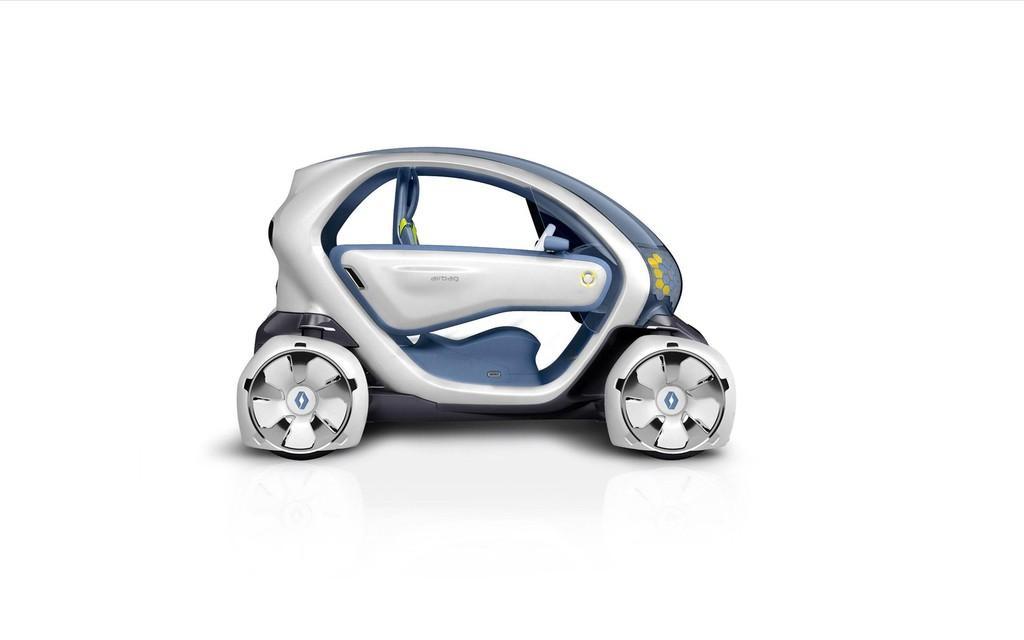How would you summarize this image in a sentence or two? In this picture we can see a car, there is a white color background. 